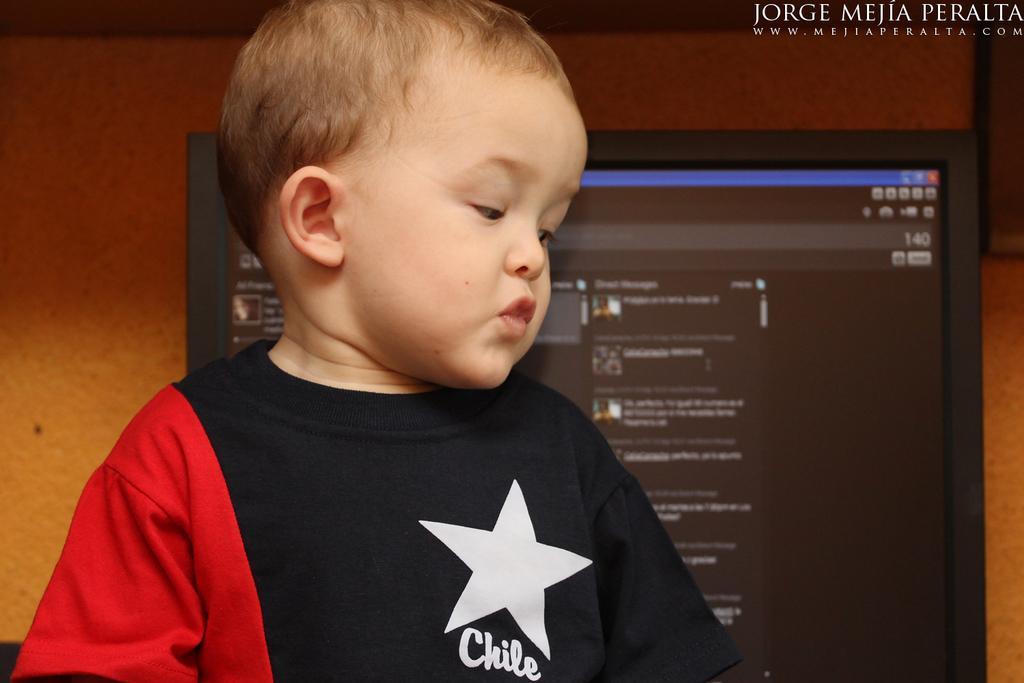In one or two sentences, can you explain what this image depicts? In this image we can see a boy and behind there is a monitor and in the background, we can see the wall and there is some text on the image. 